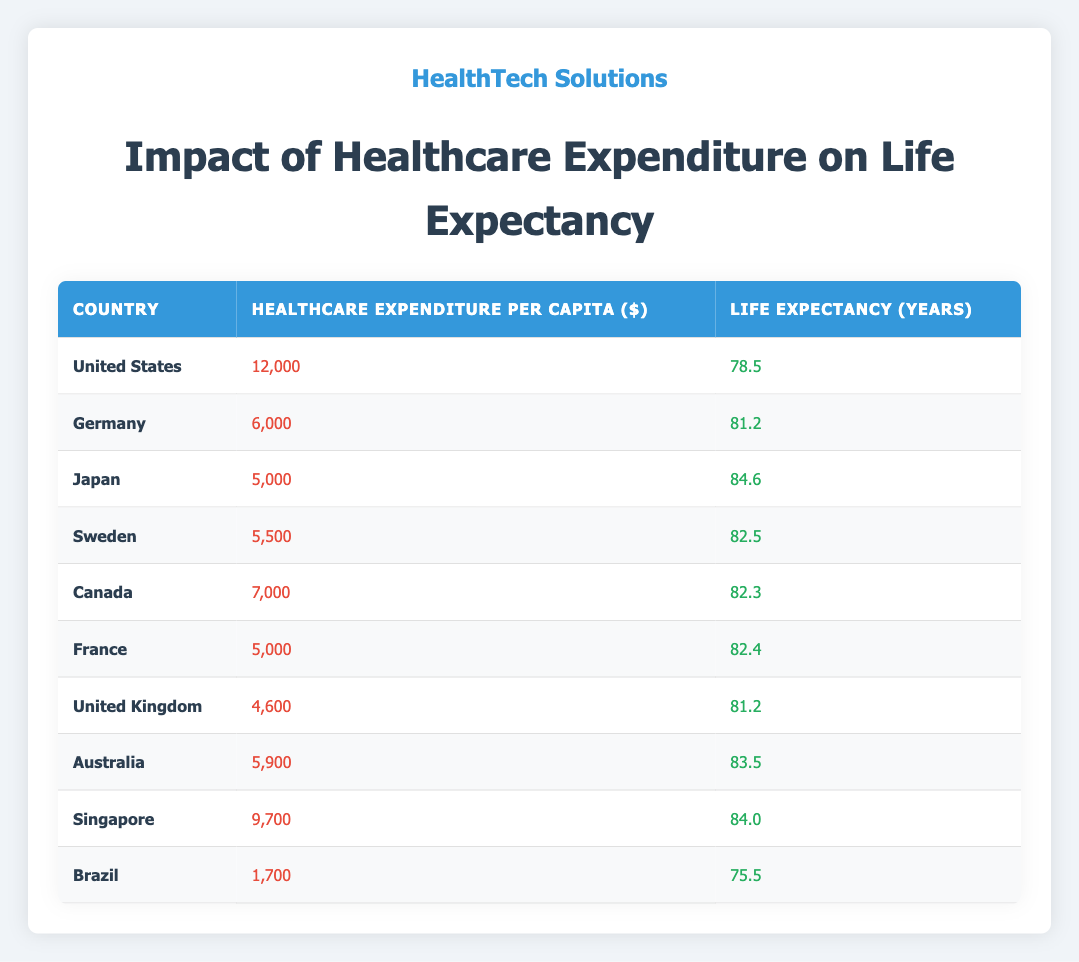What is the Healthcare Expenditure Per Capita for Japan? The table shows that Japan has a Healthcare Expenditure Per Capita of $5,000.
Answer: 5,000 Which country has the highest Life Expectancy? Japan has the highest Life Expectancy listed in the table, which is 84.6 years.
Answer: 84.6 Is the Life Expectancy in the United Kingdom higher than that in Canada? According to the table, the United Kingdom's Life Expectancy is 81.2 years, while Canada's is 82.3 years, making the statement false.
Answer: No What is the difference in Life Expectancy between the United States and Brazil? The Life Expectancy for the United States is 78.5 years, and for Brazil, it is 75.5 years. The difference is 78.5 - 75.5 = 3 years.
Answer: 3 What is the average Healthcare Expenditure Per Capita among the listed countries? To find the average, sum the Healthcare Expenditures ($12,000 + $6,000 + $5,000 + $5,500 + $7,000 + $5,000 + $4,600 + $5,900 + $9,700 + $1,700 = 58,600) and divide by the number of countries (10), which gives an average of 58,600 / 10 = 5,860.
Answer: 5,860 Does Germany have a higher Healthcare Expenditure Per Capita than Sweden? The table lists Germany's expenditure as $6,000 and Sweden's as $5,500, making the statement true since $6,000 is greater than $5,500.
Answer: Yes What country has the lowest Healthcare Expenditure Per Capita? Brazil has the lowest Healthcare Expenditure Per Capita listed in the table, which is $1,700.
Answer: 1,700 What is the total Life Expectancy of all countries combined? To find the total, sum the Life Expectancies (78.5 + 81.2 + 84.6 + 82.5 + 82.3 + 82.4 + 81.2 + 83.5 + 84.0 + 75.5 = 824.2).
Answer: 824.2 How many countries have a Life Expectancy greater than 80 years? By checking the table, Japan (84.6), Germany (81.2), Sweden (82.5), Canada (82.3), France (82.4), Australia (83.5), and Singapore (84.0) all have Life Expectancy greater than 80 years. This gives us a total of 7 countries.
Answer: 7 